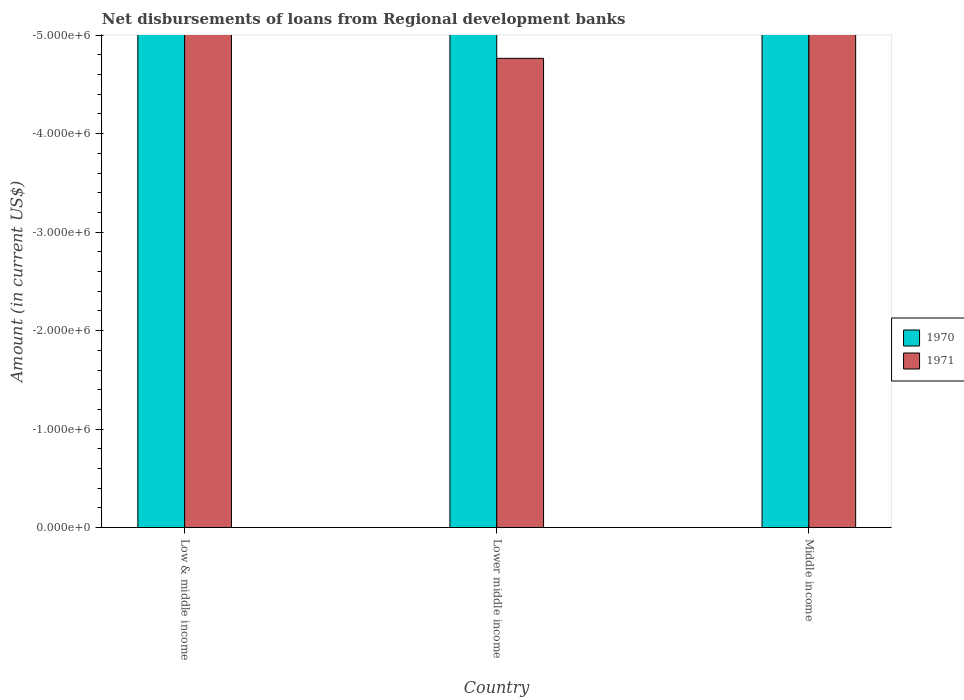How many different coloured bars are there?
Your response must be concise. 0. Are the number of bars per tick equal to the number of legend labels?
Make the answer very short. No. How many bars are there on the 1st tick from the left?
Keep it short and to the point. 0. How many bars are there on the 2nd tick from the right?
Your answer should be very brief. 0. What is the label of the 2nd group of bars from the left?
Provide a succinct answer. Lower middle income. In how many cases, is the number of bars for a given country not equal to the number of legend labels?
Your answer should be very brief. 3. What is the difference between the amount of disbursements of loans from regional development banks in 1970 in Lower middle income and the amount of disbursements of loans from regional development banks in 1971 in Low & middle income?
Offer a terse response. 0. What is the average amount of disbursements of loans from regional development banks in 1970 per country?
Give a very brief answer. 0. Are all the bars in the graph horizontal?
Keep it short and to the point. No. How many countries are there in the graph?
Offer a very short reply. 3. What is the difference between two consecutive major ticks on the Y-axis?
Provide a short and direct response. 1.00e+06. Does the graph contain any zero values?
Ensure brevity in your answer.  Yes. Where does the legend appear in the graph?
Offer a terse response. Center right. What is the title of the graph?
Make the answer very short. Net disbursements of loans from Regional development banks. Does "1987" appear as one of the legend labels in the graph?
Make the answer very short. No. What is the label or title of the Y-axis?
Provide a short and direct response. Amount (in current US$). What is the Amount (in current US$) of 1970 in Lower middle income?
Give a very brief answer. 0. What is the Amount (in current US$) of 1970 in Middle income?
Your response must be concise. 0. What is the Amount (in current US$) of 1971 in Middle income?
Give a very brief answer. 0. What is the total Amount (in current US$) of 1970 in the graph?
Your answer should be compact. 0. What is the average Amount (in current US$) in 1971 per country?
Offer a very short reply. 0. 